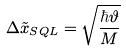<formula> <loc_0><loc_0><loc_500><loc_500>\Delta \tilde { x } _ { S Q L } = \sqrt { \frac { \hbar { \vartheta } } { M } }</formula> 